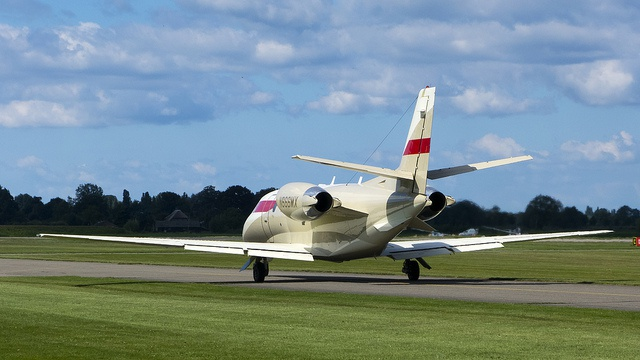Describe the objects in this image and their specific colors. I can see a airplane in darkgray, ivory, gray, black, and beige tones in this image. 